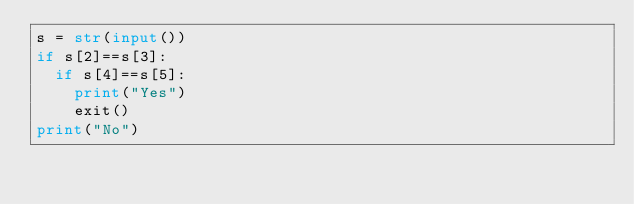Convert code to text. <code><loc_0><loc_0><loc_500><loc_500><_Python_>s = str(input())
if s[2]==s[3]:
  if s[4]==s[5]:
    print("Yes")
    exit()
print("No")</code> 